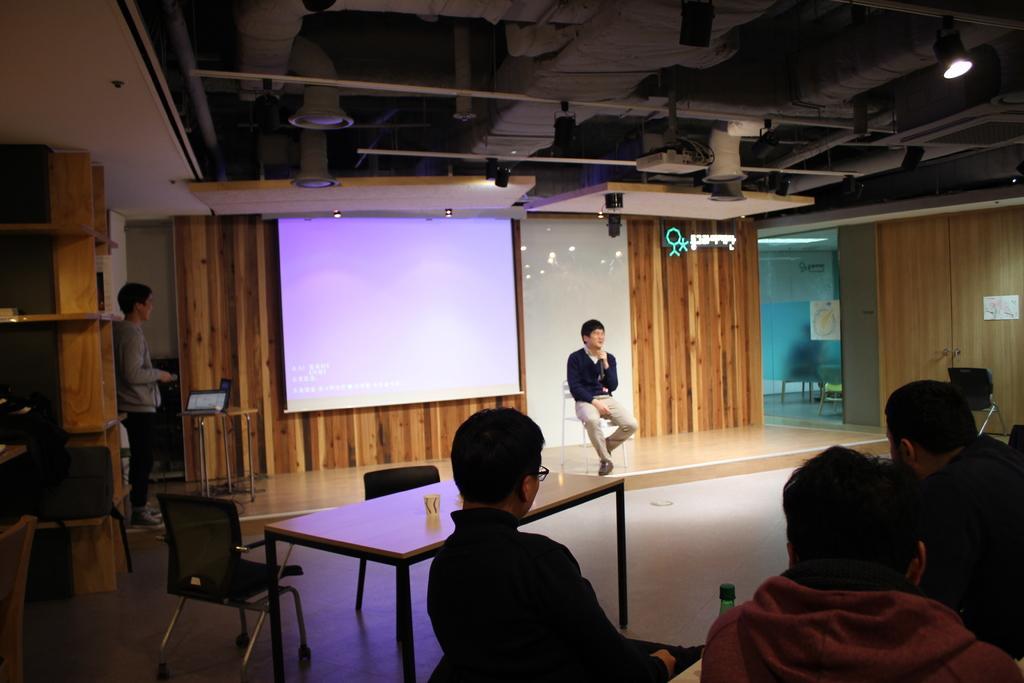Could you give a brief overview of what you see in this image? In this image I can see number of people where one man is sitting on a stool. here I can see a laptop and a projector screen. 